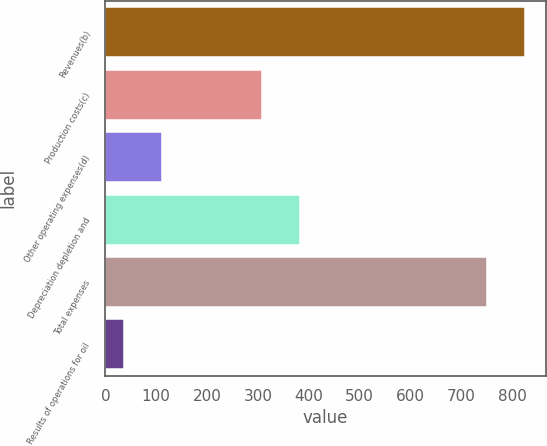<chart> <loc_0><loc_0><loc_500><loc_500><bar_chart><fcel>Revenues(b)<fcel>Production costs(c)<fcel>Other operating expenses(d)<fcel>Depreciation depletion and<fcel>Total expenses<fcel>Results of operations for oil<nl><fcel>824.56<fcel>308.4<fcel>110.86<fcel>383.36<fcel>749.6<fcel>35.9<nl></chart> 